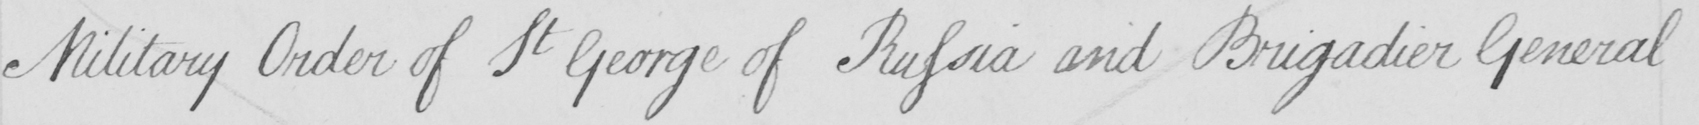What text is written in this handwritten line? Military Order of St George of Russia and Brigadier General 